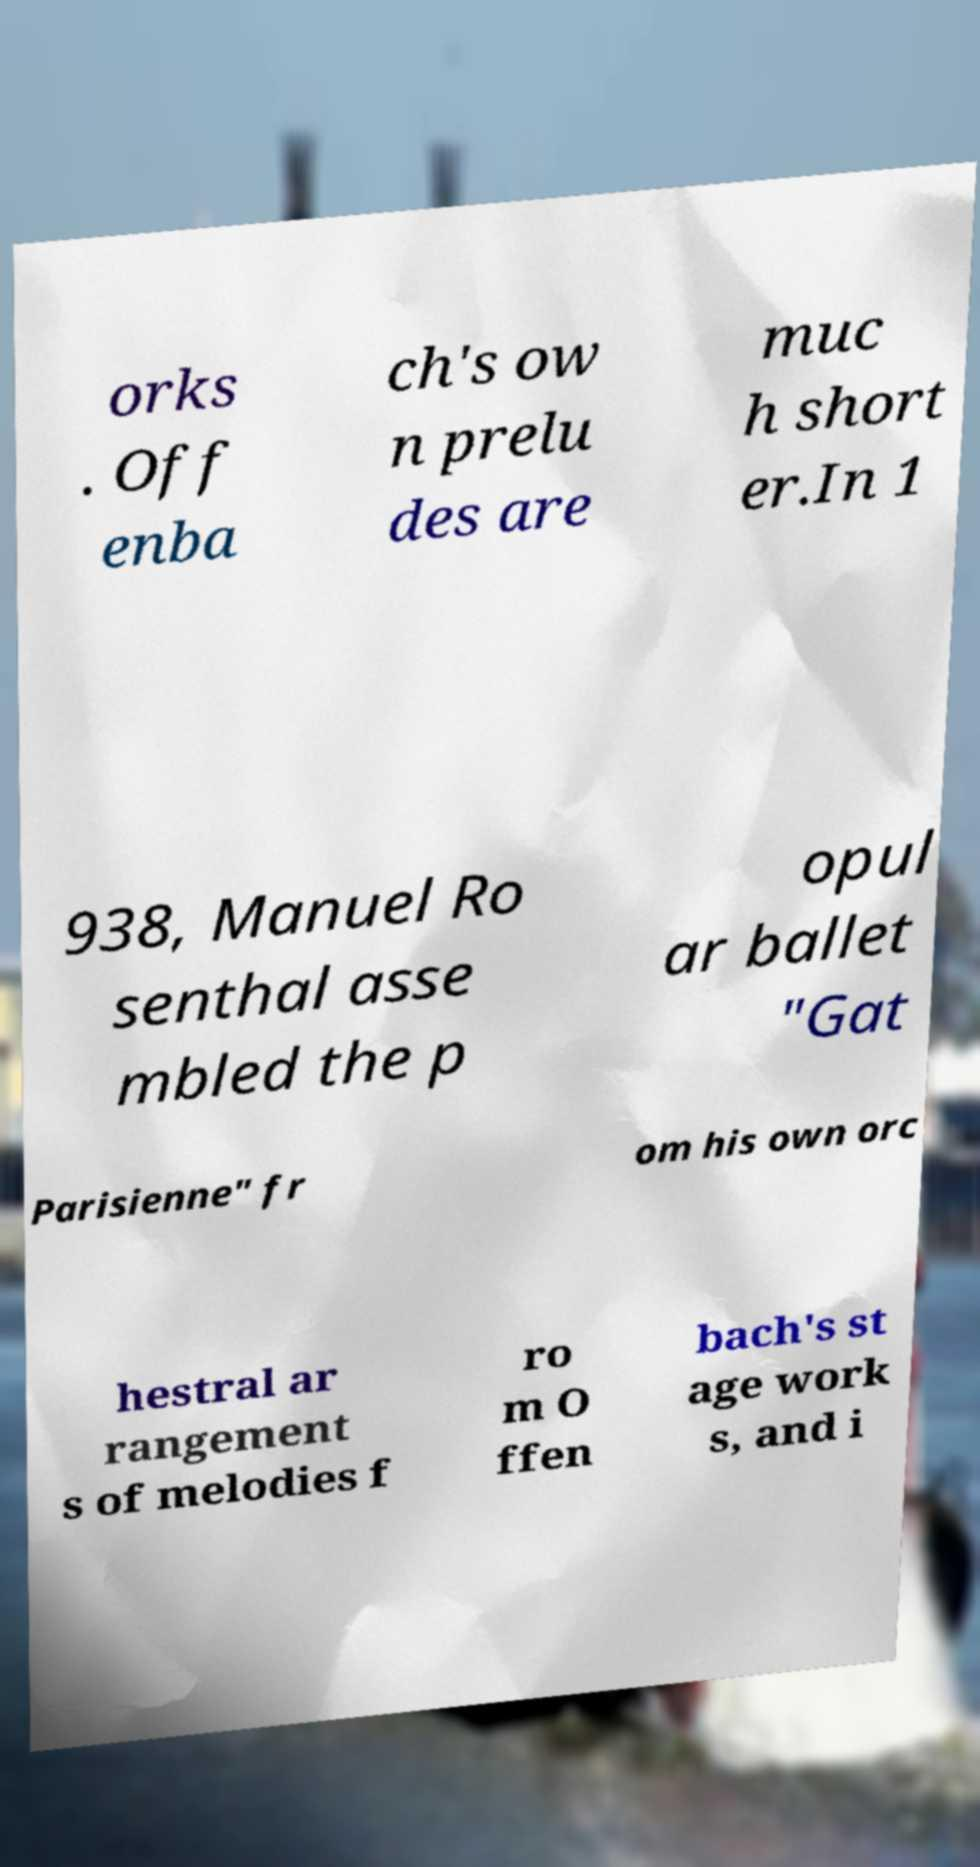Can you accurately transcribe the text from the provided image for me? orks . Off enba ch's ow n prelu des are muc h short er.In 1 938, Manuel Ro senthal asse mbled the p opul ar ballet "Gat Parisienne" fr om his own orc hestral ar rangement s of melodies f ro m O ffen bach's st age work s, and i 